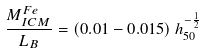<formula> <loc_0><loc_0><loc_500><loc_500>\frac { M _ { I C M } ^ { F e } } { L _ { B } } = ( 0 . 0 1 - 0 . 0 1 5 ) \, h _ { 5 0 } ^ { - \frac { 1 } { 2 } }</formula> 